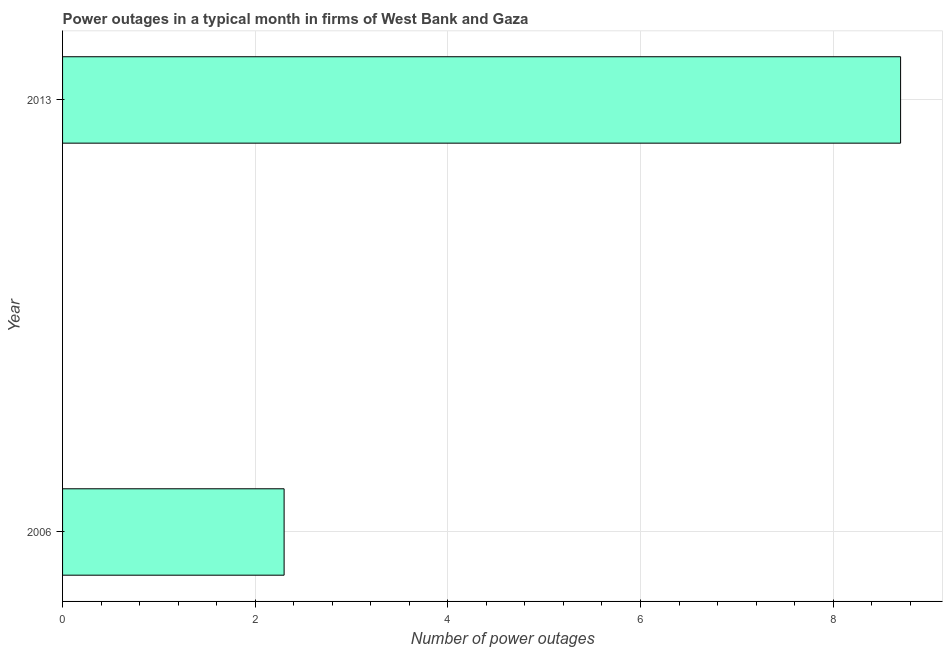What is the title of the graph?
Your answer should be very brief. Power outages in a typical month in firms of West Bank and Gaza. What is the label or title of the X-axis?
Make the answer very short. Number of power outages. Across all years, what is the minimum number of power outages?
Provide a short and direct response. 2.3. In which year was the number of power outages minimum?
Your answer should be compact. 2006. What is the sum of the number of power outages?
Offer a very short reply. 11. What is the ratio of the number of power outages in 2006 to that in 2013?
Give a very brief answer. 0.26. In how many years, is the number of power outages greater than the average number of power outages taken over all years?
Give a very brief answer. 1. How many bars are there?
Your answer should be very brief. 2. Are all the bars in the graph horizontal?
Your answer should be very brief. Yes. How many years are there in the graph?
Give a very brief answer. 2. What is the difference between two consecutive major ticks on the X-axis?
Provide a short and direct response. 2. What is the difference between the Number of power outages in 2006 and 2013?
Your response must be concise. -6.4. What is the ratio of the Number of power outages in 2006 to that in 2013?
Ensure brevity in your answer.  0.26. 